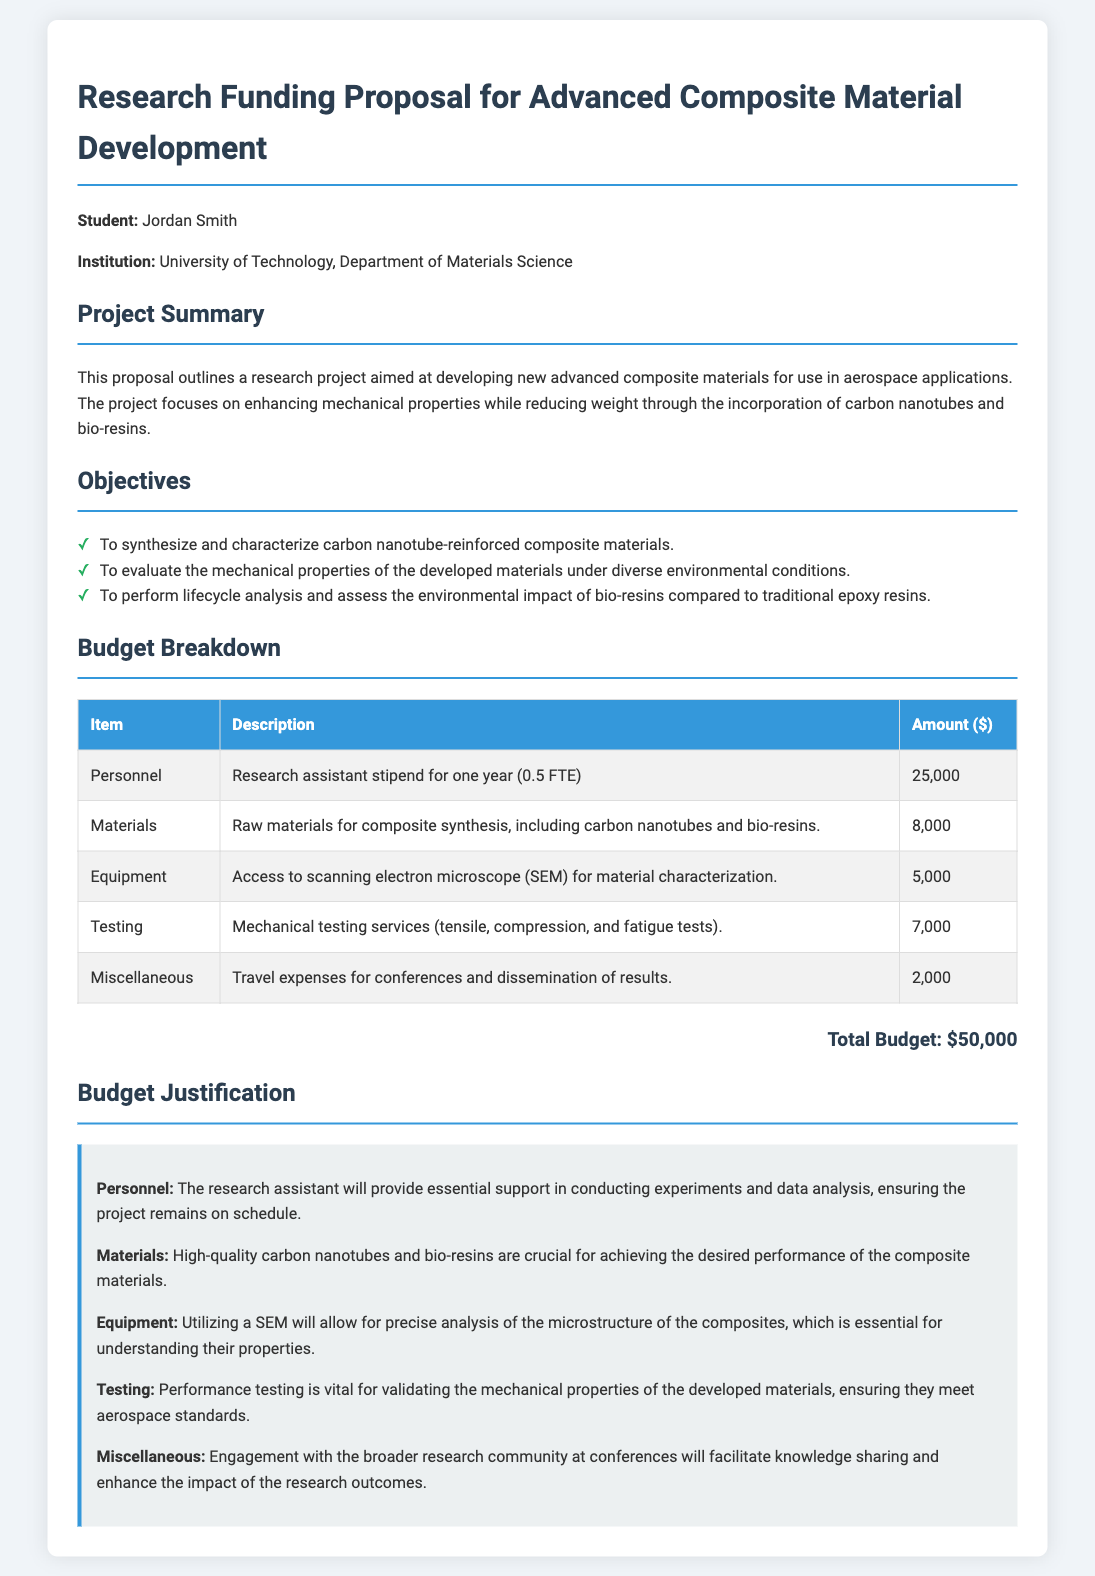What is the title of the proposal? The title of the proposal is explicitly stated at the beginning of the document as "Research Funding Proposal for Advanced Composite Material Development."
Answer: Research Funding Proposal for Advanced Composite Material Development Who is the principal investigator? The document lists the student, Jordan Smith, as the principal investigator leading the project.
Answer: Jordan Smith What is the budget for materials? The budget breakdown indicates that the amount allocated for materials is listed in the table as $8,000.
Answer: $8,000 What percentage of the budget is allocated to personnel? The total budget is $50,000, and personnel costs are $25,000, making the percentage allocated to personnel 50%.
Answer: 50% What type of materials are to be used for the project? The project aims to use carbon nanotubes and bio-resins as the raw materials for composite synthesis, as mentioned in the budget breakdown.
Answer: Carbon nanotubes and bio-resins What is the main objective of the project? The primary objective mentioned in the proposal focuses on enhancing mechanical properties and reducing weight using advanced composite materials.
Answer: Enhancing mechanical properties and reducing weight How much is allocated for mechanical testing services? The budget table lists the amount allocated for mechanical testing services as $7,000.
Answer: $7,000 Which piece of equipment will be accessed for material characterization? The document states that access to a scanning electron microscope (SEM) will be utilized for material characterization.
Answer: Scanning electron microscope (SEM) What is the purpose of the miscellaneous budget category? The miscellaneous category includes travel expenses for conferences and dissemination of results to engage with the research community, stated in the budget justification.
Answer: Travel expenses for conferences What is the total budget for the project? The total budget figure is explicitly stated at the bottom of the budget breakdown section as $50,000.
Answer: $50,000 